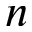<formula> <loc_0><loc_0><loc_500><loc_500>n</formula> 